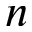<formula> <loc_0><loc_0><loc_500><loc_500>n</formula> 